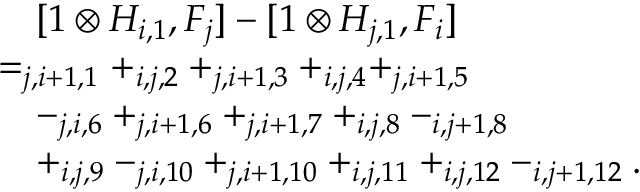Convert formula to latex. <formula><loc_0><loc_0><loc_500><loc_500>\begin{array} { r l } & { \quad [ 1 \otimes H _ { i , 1 } , F _ { j } ] - [ 1 \otimes H _ { j , 1 } , F _ { i } ] } \\ & { = _ { j , i + 1 , 1 } + _ { i , j , 2 } + _ { j , i + 1 , 3 } + _ { i , j , 4 } + _ { j , i + 1 , 5 } } \\ & { \quad - _ { j , i , 6 } + _ { j , i + 1 , 6 } + _ { j , i + 1 , 7 } + _ { i , j , 8 } - _ { i , j + 1 , 8 } } \\ & { \quad + _ { i , j , 9 } - _ { j , i , 1 0 } + _ { j , i + 1 , 1 0 } + _ { i , j , 1 1 } + _ { i , j , 1 2 } - _ { i , j + 1 , 1 2 } . } \end{array}</formula> 